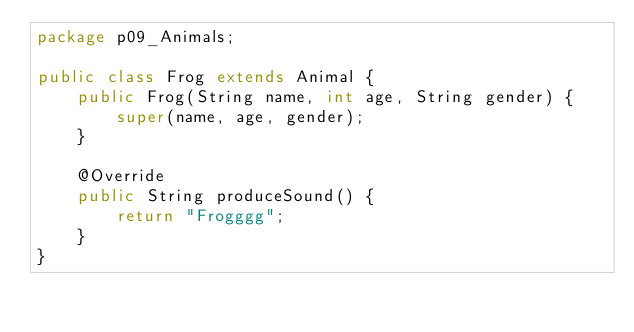Convert code to text. <code><loc_0><loc_0><loc_500><loc_500><_Java_>package p09_Animals;

public class Frog extends Animal {
    public Frog(String name, int age, String gender) {
        super(name, age, gender);
    }

    @Override
    public String produceSound() {
        return "Frogggg";
    }
}
</code> 